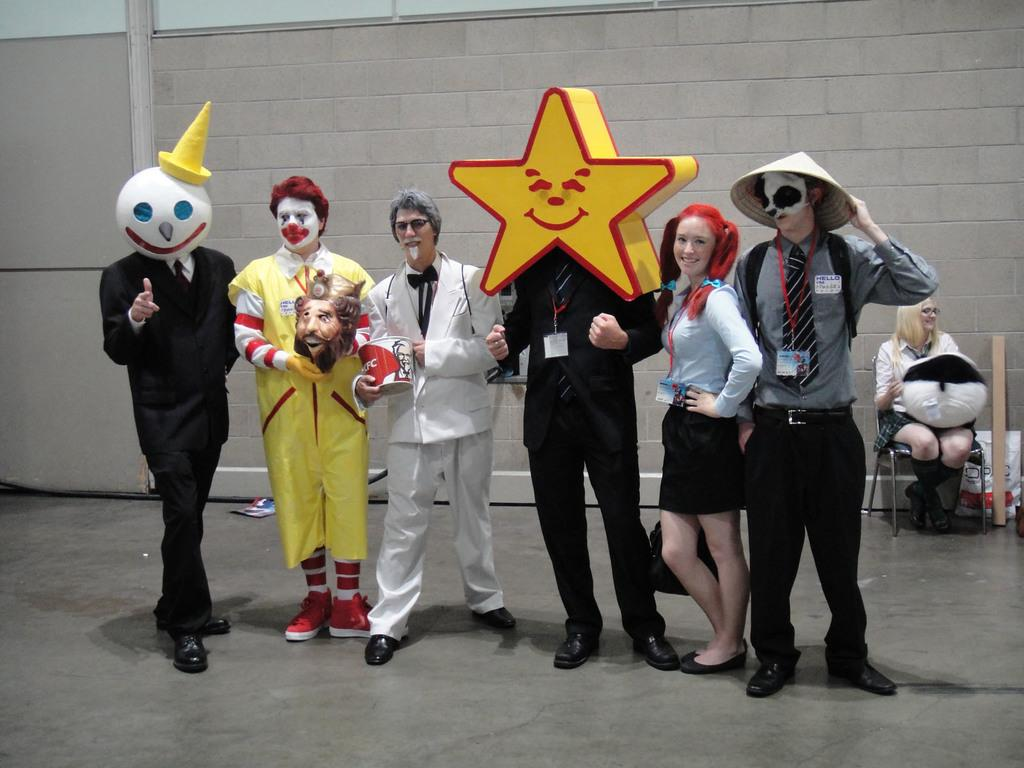What are the people in the image doing? The people in the image are standing and smiling. What are the people wearing in the image? The people are wearing different costumes in the image. Can you describe the woman in the backdrop? There is a woman sitting in the backdrop of the image. What is visible behind the people in the image? There is a wall visible in the backdrop of the image. What type of insect can be seen crawling on the toothbrush in the image? There is no toothbrush or insect present in the image. 